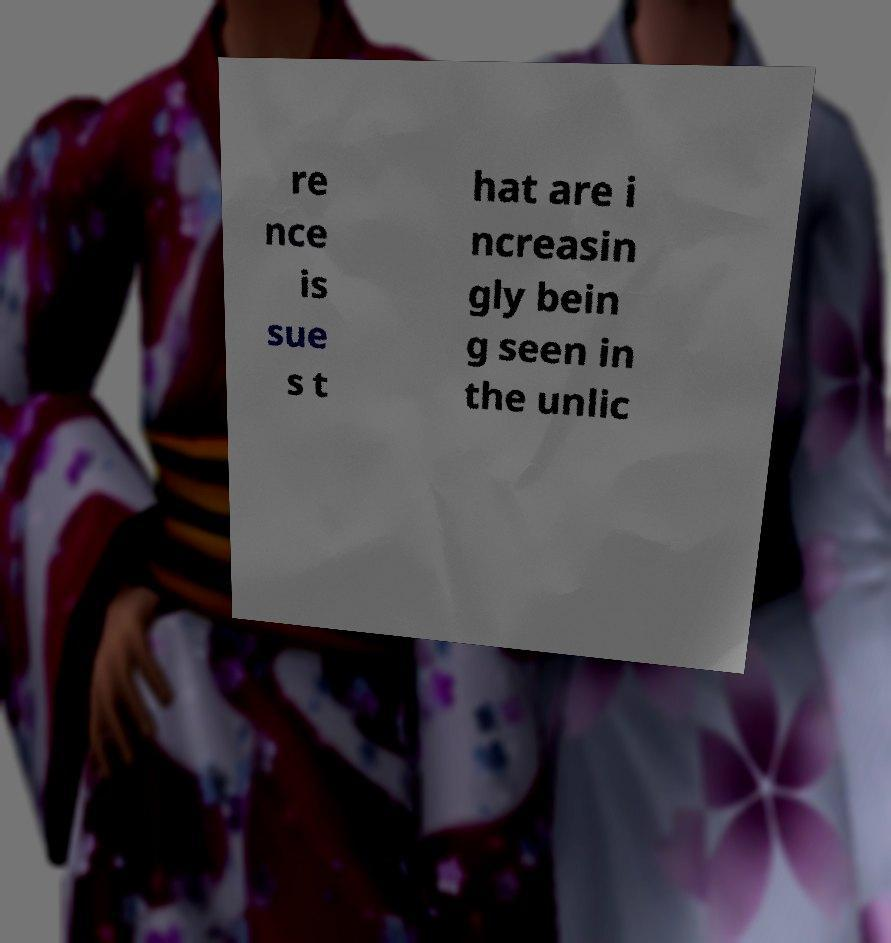Can you accurately transcribe the text from the provided image for me? re nce is sue s t hat are i ncreasin gly bein g seen in the unlic 